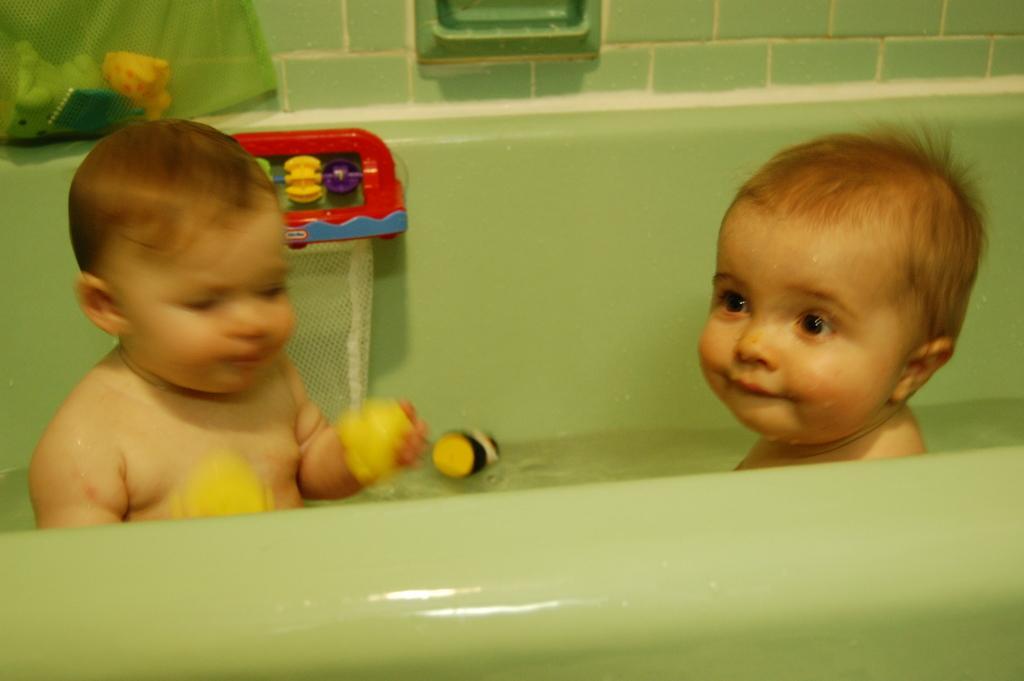Can you describe this image briefly? In this picture, we can see two children playing with toys and water in a tub and we can see the tub, and in the background, we can see the wall with soap stand and we can find some objects top left corner. 